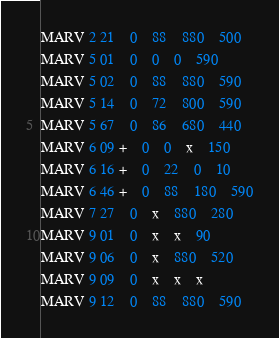<code> <loc_0><loc_0><loc_500><loc_500><_Python_>MARV 2 21	0	88	880	500
MARV 5 01	0	0	0	590
MARV 5 02	0	88	880	590
MARV 5 14	0	72	800	590
MARV 5 67	0	86	680	440
MARV 6 09 +	0	0	x	150
MARV 6 16 +	0	22	0	10
MARV 6 46 +	0	88	180	590
MARV 7 27	0	x	880	280
MARV 9 01	0	x	x	90
MARV 9 06	0	x	880	520
MARV 9 09	0	x	x	x
MARV 9 12	0	88	880	590
</code> 